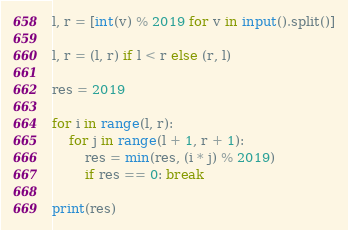<code> <loc_0><loc_0><loc_500><loc_500><_Python_>l, r = [int(v) % 2019 for v in input().split()]

l, r = (l, r) if l < r else (r, l)

res = 2019

for i in range(l, r):
    for j in range(l + 1, r + 1):
        res = min(res, (i * j) % 2019)
        if res == 0: break

print(res)
</code> 